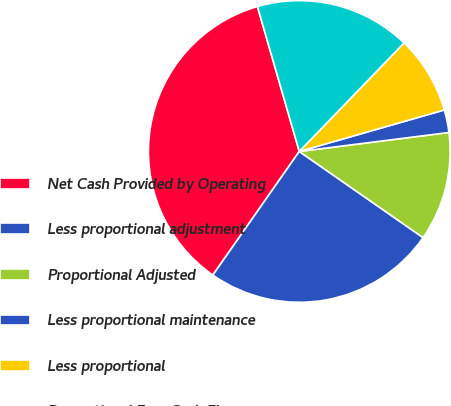<chart> <loc_0><loc_0><loc_500><loc_500><pie_chart><fcel>Net Cash Provided by Operating<fcel>Less proportional adjustment<fcel>Proportional Adjusted<fcel>Less proportional maintenance<fcel>Less proportional<fcel>Proportional Free Cash Flow<nl><fcel>35.81%<fcel>25.03%<fcel>11.68%<fcel>2.43%<fcel>8.34%<fcel>16.69%<nl></chart> 